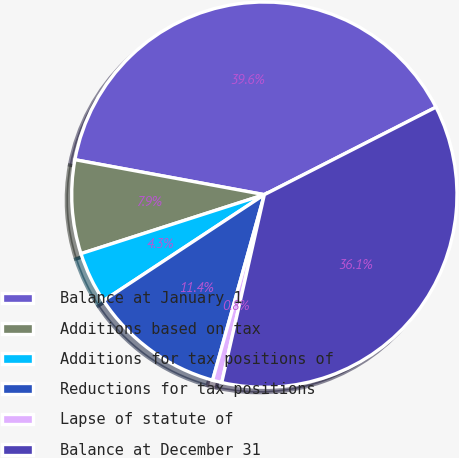<chart> <loc_0><loc_0><loc_500><loc_500><pie_chart><fcel>Balance at January 1<fcel>Additions based on tax<fcel>Additions for tax positions of<fcel>Reductions for tax positions<fcel>Lapse of statute of<fcel>Balance at December 31<nl><fcel>39.6%<fcel>7.86%<fcel>4.32%<fcel>11.4%<fcel>0.78%<fcel>36.06%<nl></chart> 